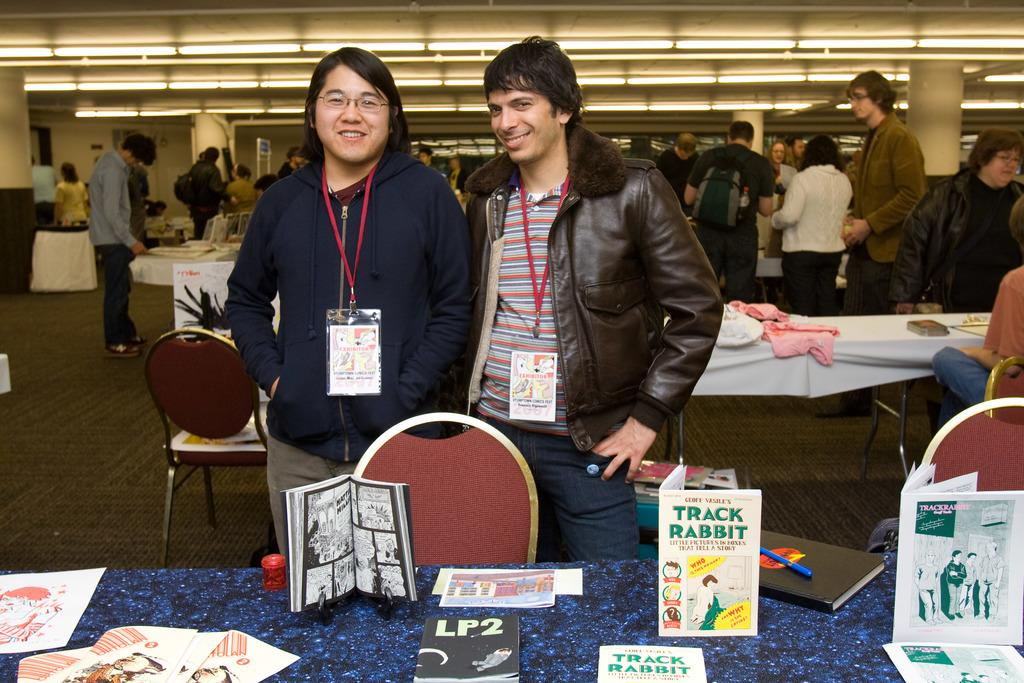Provide a one-sentence caption for the provided image. Two men standing in front of a table with some books on display like Track Rabbit. 